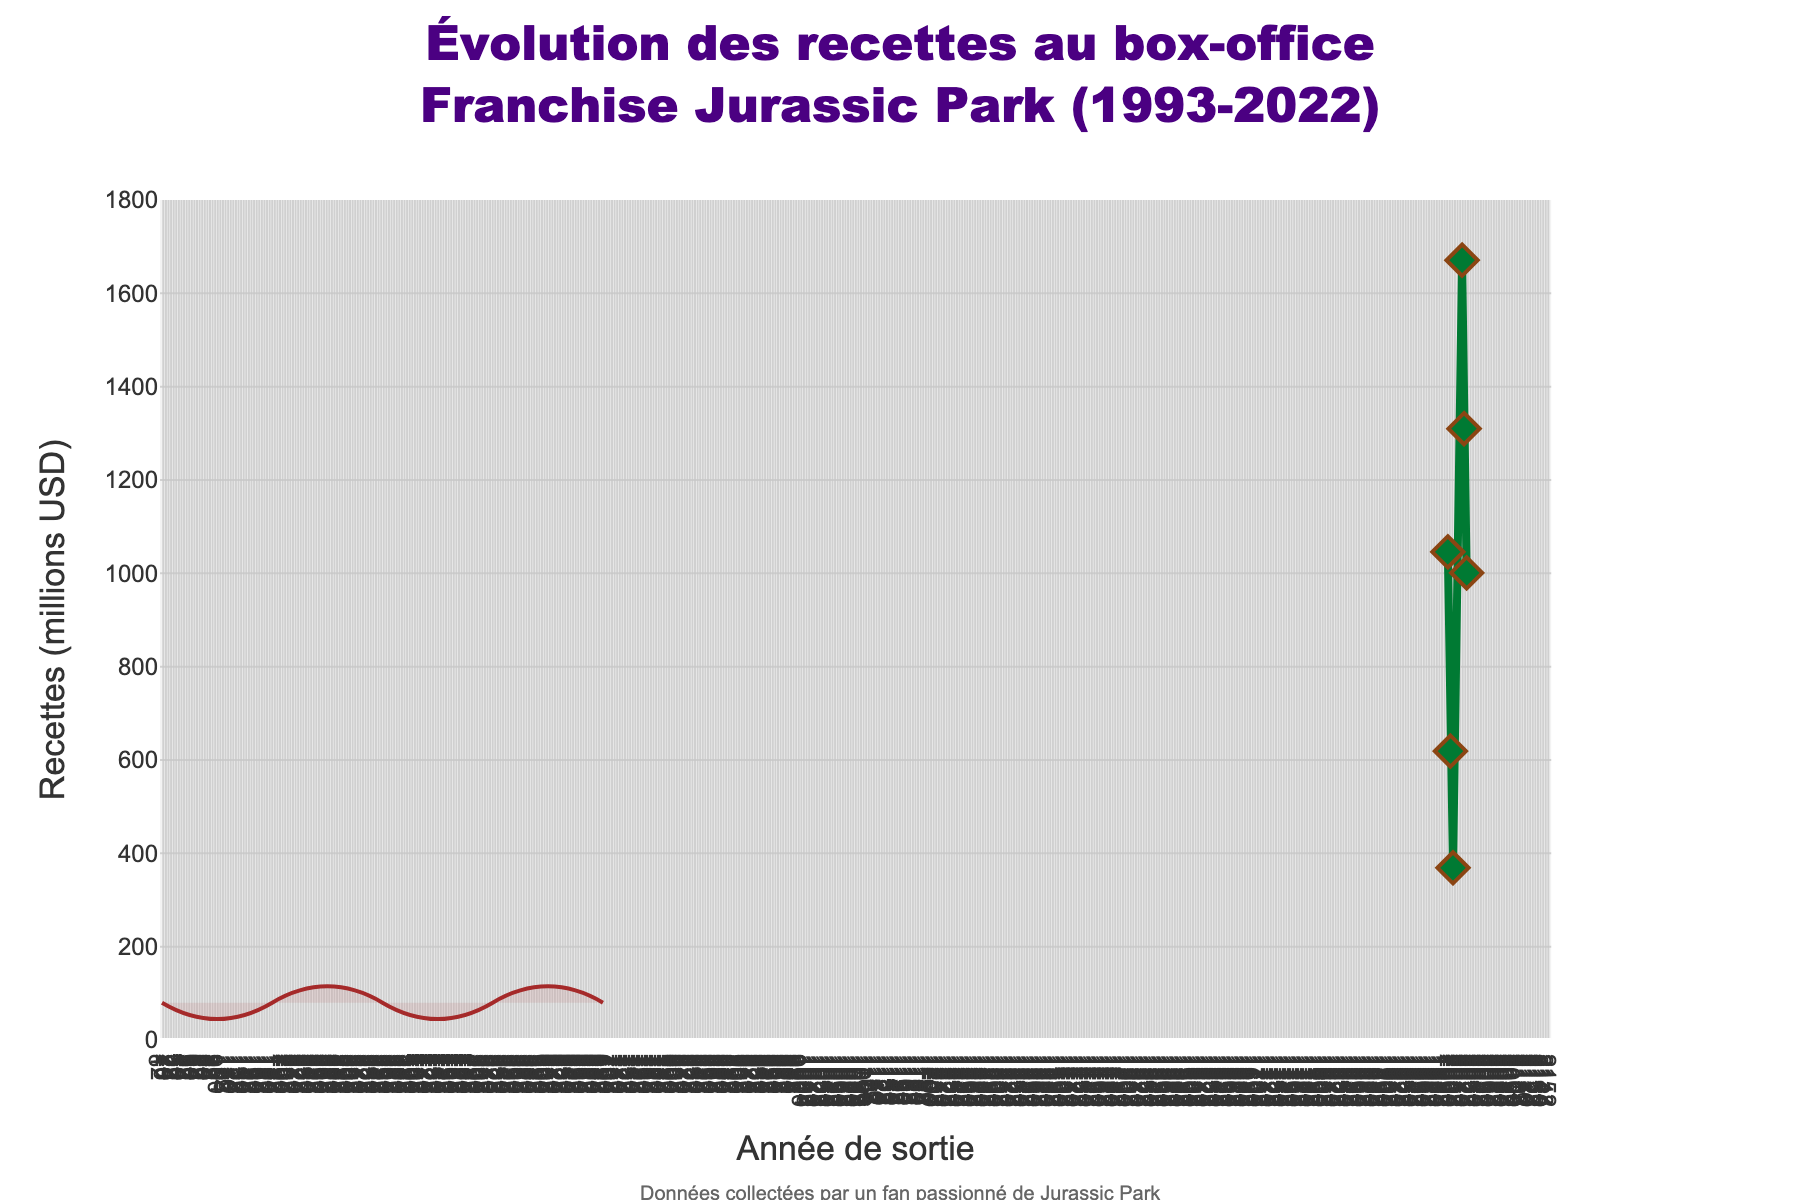What's the total box office revenue for the Jurassic Park franchise from 1993 to 2022? Sum the revenues of each year: 1046 + 619 + 369 + 1671 + 1310 + 1001, which equals 6016 millions USD.
Answer: 6016 millions USD In which year did the Jurassic Park movie release with the lowest box office revenue? Identify the data point with the lowest value in the series. The lowest revenue is 369 millions USD in 2001.
Answer: 2001 How much more revenue did Jurassic World (2015) generate compared to Jurassic Park III (2001)? Subtract the 2001 revenue from the 2015 revenue: 1671 - 369 which gives 1302 millions USD.
Answer: 1302 millions USD What is the average box office revenue of the Jurassic Park movies released in the 1990s? Calculate the mean for the years 1993 and 1997: (1046 + 619) / 2, which is 832.5 millions USD.
Answer: 832.5 millions USD Among the movies released after 2010, which one had higher box office revenue and by how much? Compare revenues of movies from 2015, 2018, and 2022. 2015 had the highest, and 2018 was higher than 2022 by 1310 - 1001 = 309 millions USD.
Answer: Jurassic World (2015), 309 millions USD Was there an increase or decrease in box office revenue from the first Jurassic Park movie to the first Jurassic World movie? Compare the revenues for 1993 and 2015: 1671 (2015) - 1046 (1993) = 625 millions USD increase.
Answer: Increase What's the difference in box office revenue between the highest-grossing and the lowest-grossing Jurassic Park movie? Subtract the lowest revenue from the highest revenue: 1671 - 369, which equates to 1302 millions USD.
Answer: 1302 millions USD How many movies had box office revenues exceeding 1000 millions USD? Count the years where revenues are above 1000: 1993, 2015, 2018, 2022. There are 4 such movies.
Answer: 4 